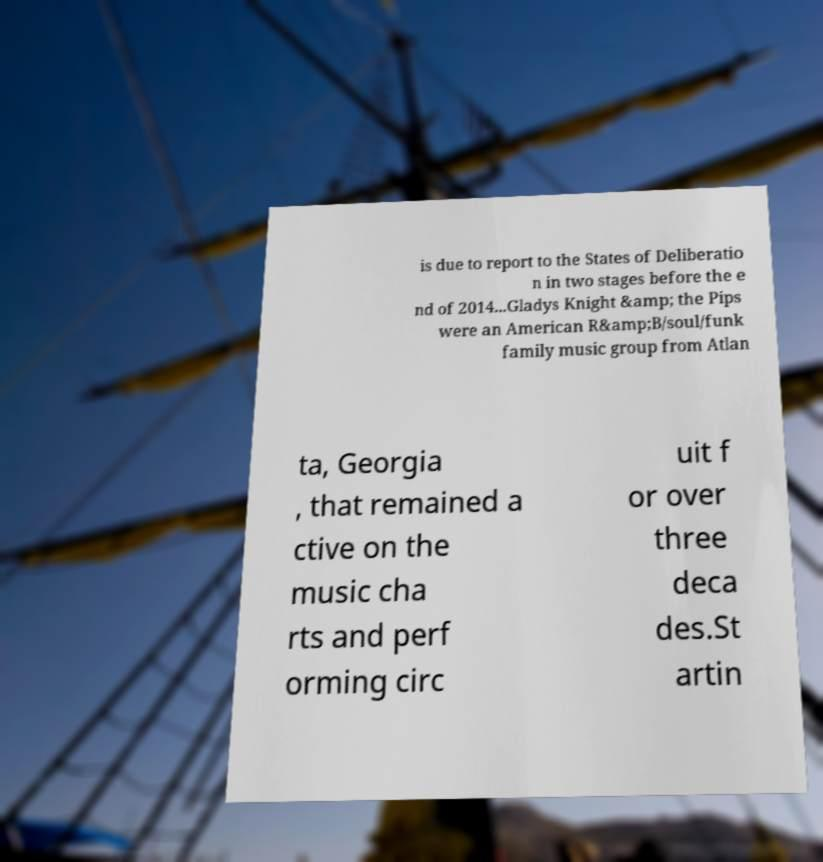There's text embedded in this image that I need extracted. Can you transcribe it verbatim? is due to report to the States of Deliberatio n in two stages before the e nd of 2014...Gladys Knight &amp; the Pips were an American R&amp;B/soul/funk family music group from Atlan ta, Georgia , that remained a ctive on the music cha rts and perf orming circ uit f or over three deca des.St artin 